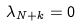Convert formula to latex. <formula><loc_0><loc_0><loc_500><loc_500>\lambda _ { N + k } = 0</formula> 